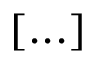Convert formula to latex. <formula><loc_0><loc_0><loc_500><loc_500>[ \dots ]</formula> 